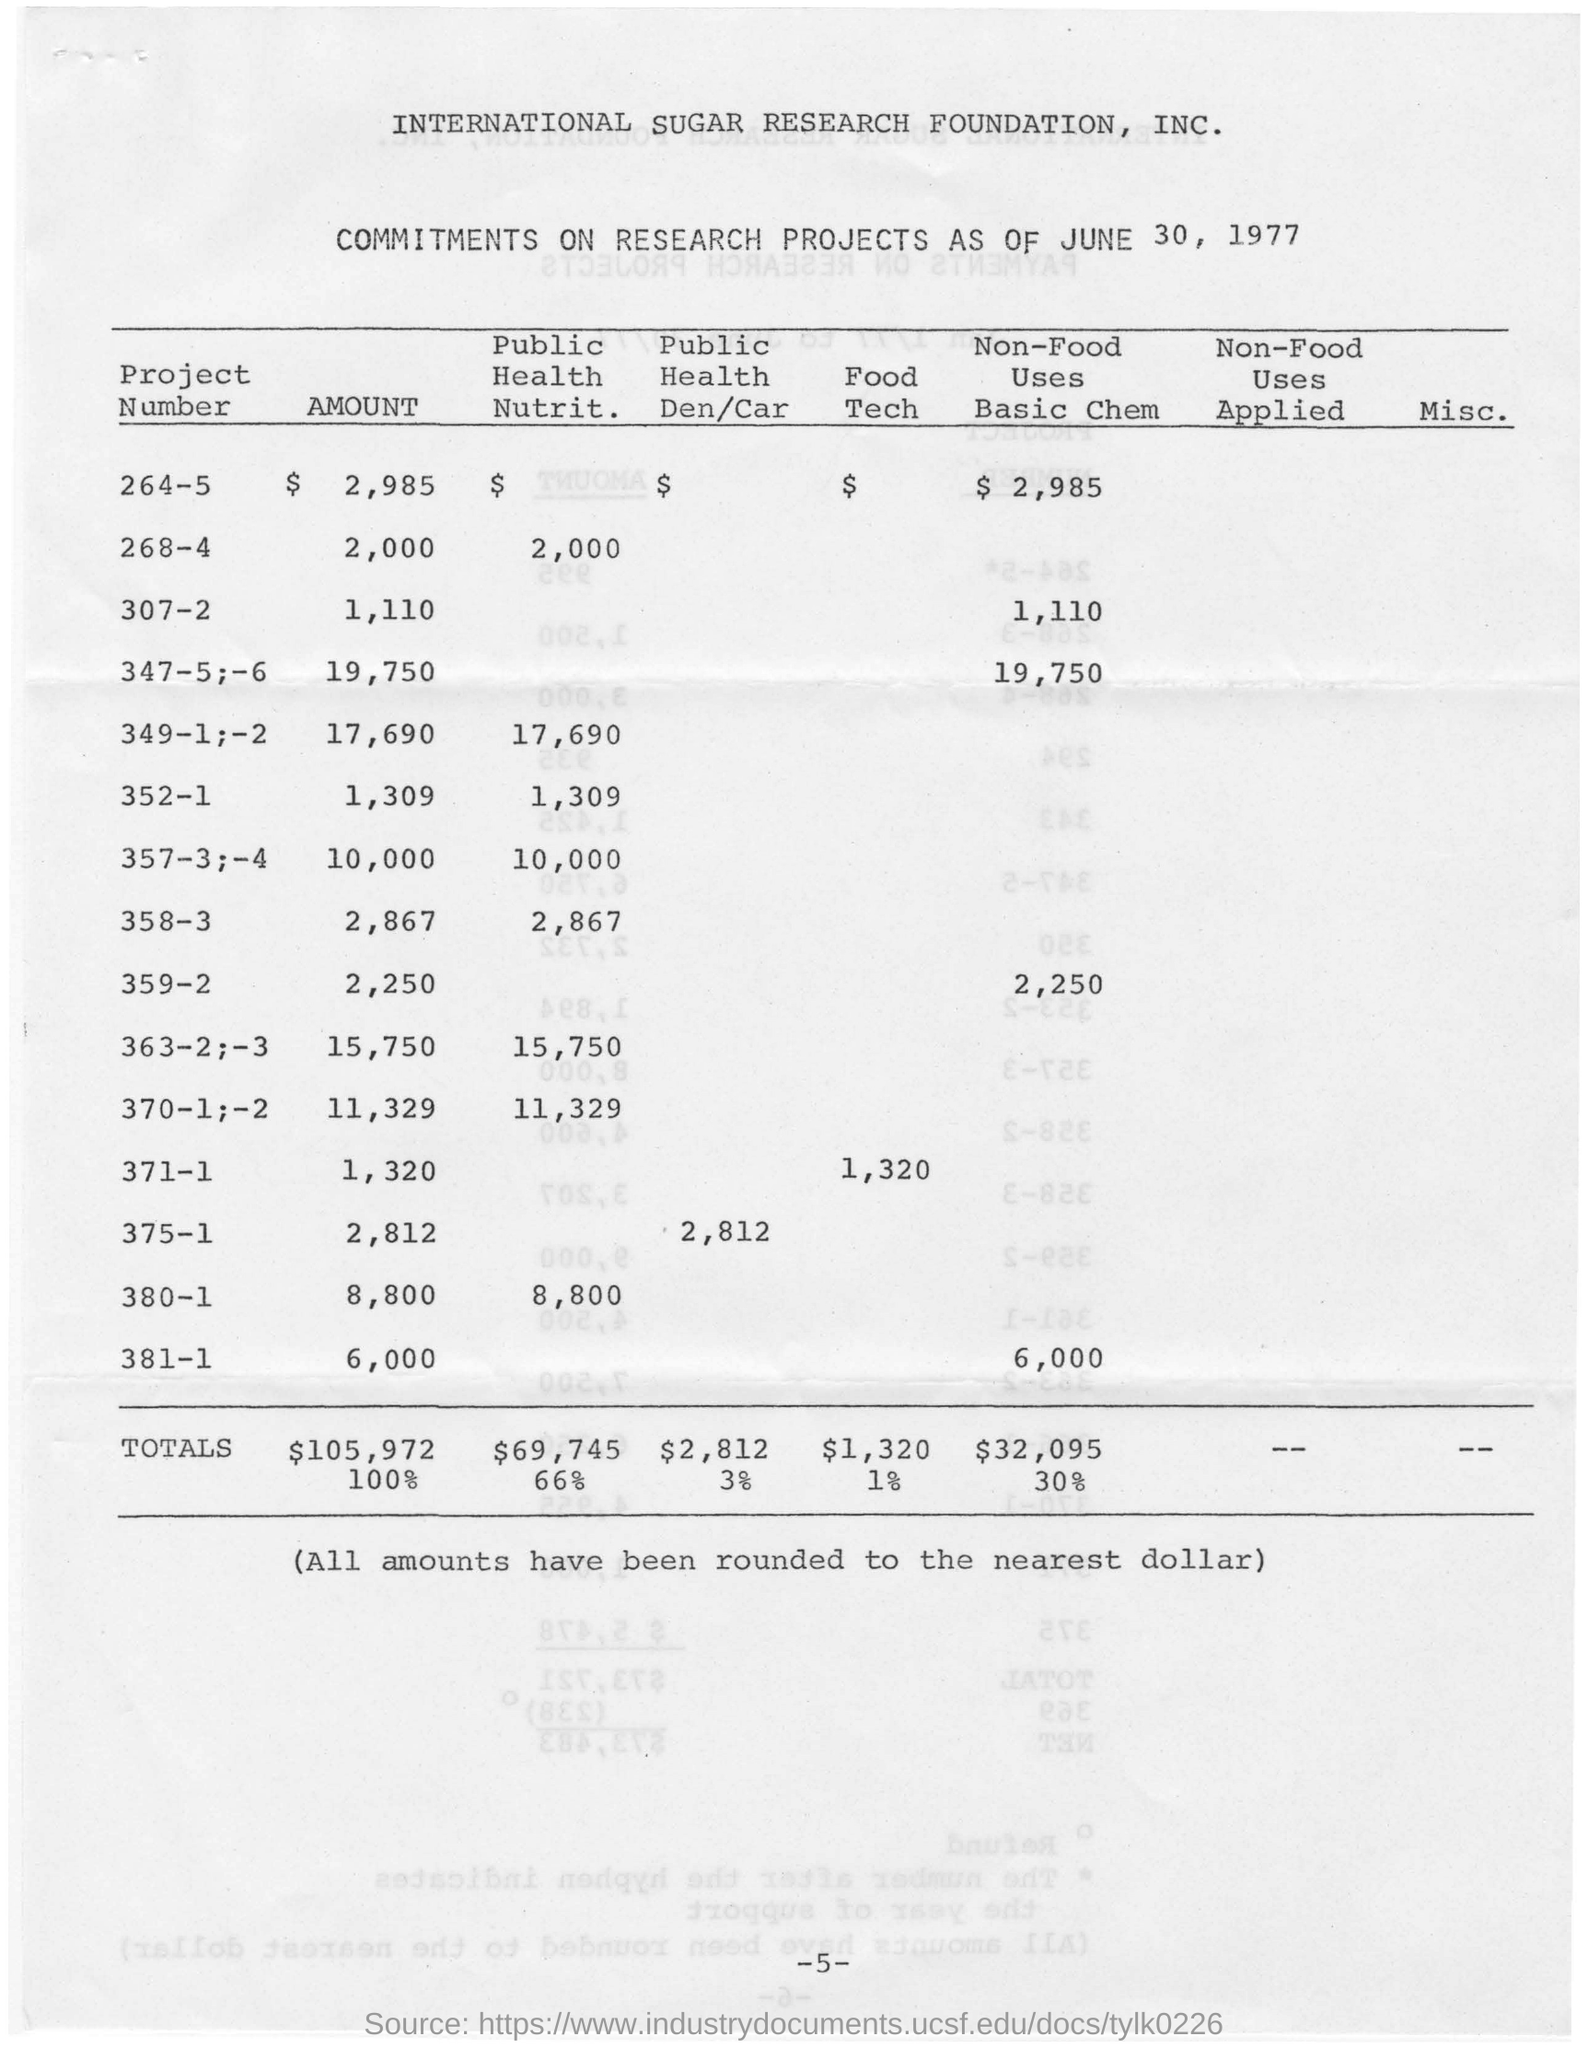What is the date mentioned in the top of the document ?
Give a very brief answer. June 30, 1977. How much total amount of the Public Health Nutrit ?
Keep it short and to the point. $69,745. 